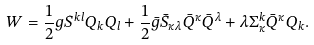Convert formula to latex. <formula><loc_0><loc_0><loc_500><loc_500>W = \frac { 1 } { 2 } g S ^ { k l } Q _ { k } Q _ { l } + \frac { 1 } { 2 } \bar { g } \bar { S } _ { \kappa \lambda } \bar { Q } ^ { \kappa } \bar { Q } ^ { \lambda } + \lambda \Sigma _ { \kappa } ^ { k } \bar { Q } ^ { \kappa } Q _ { k } .</formula> 